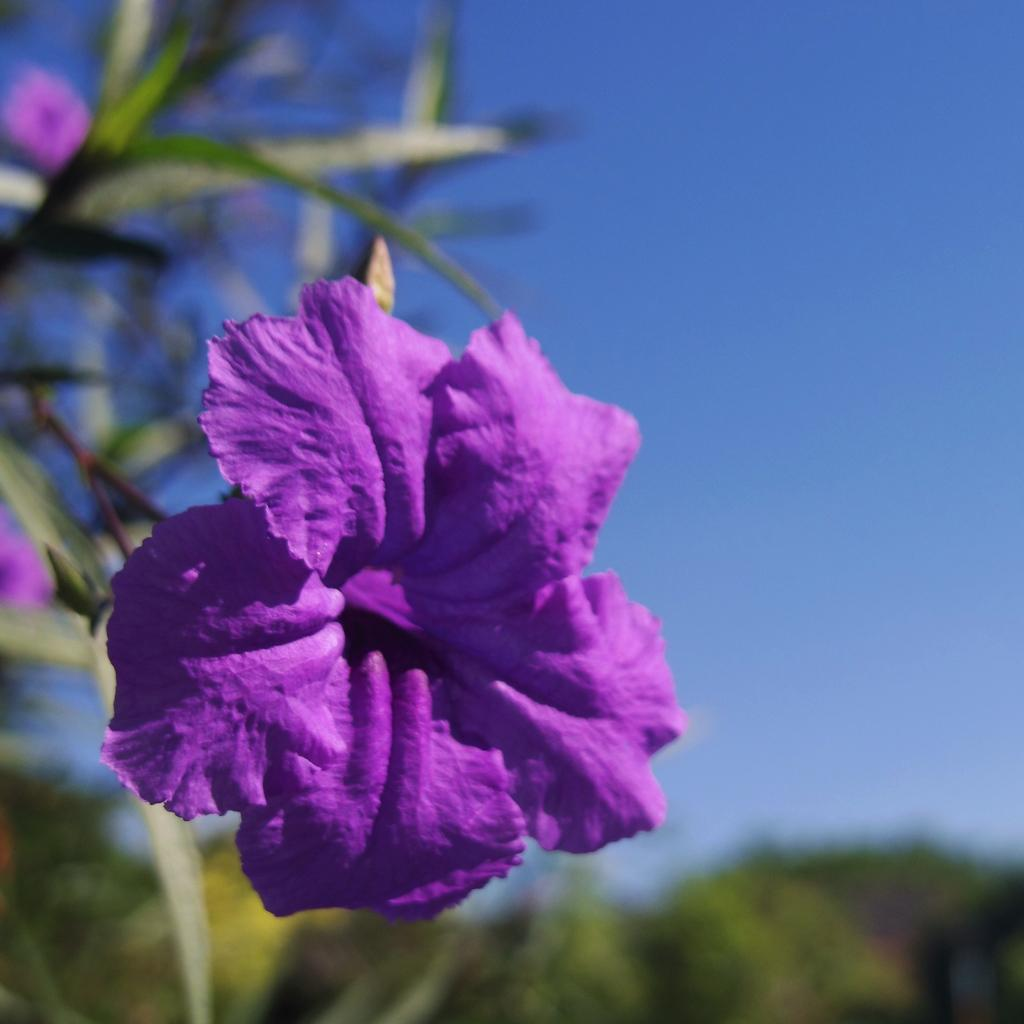What type of plant is visible in the image? There is a plant with flowers in the image. Can you describe the background of the image? The background of the image is blurred. What part of the natural environment is visible in the image? The sky is visible in the background of the image. What type of amusement can be seen in the image? There is no amusement present in the image; it features a plant with flowers and a blurred background with the sky visible. What type of nail is being used to hold the plant in the image? There is no nail present in the image; the plant is not attached to anything. 